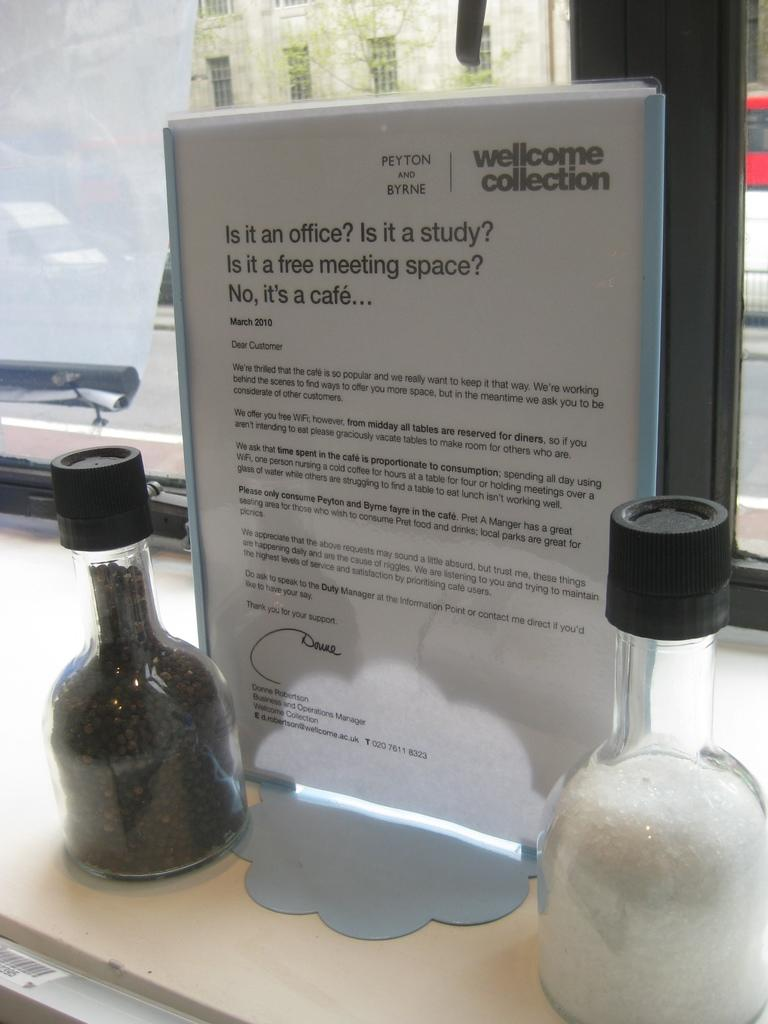<image>
Relay a brief, clear account of the picture shown. A display sign welcomes people to Peyton and Byrnes cafe. 